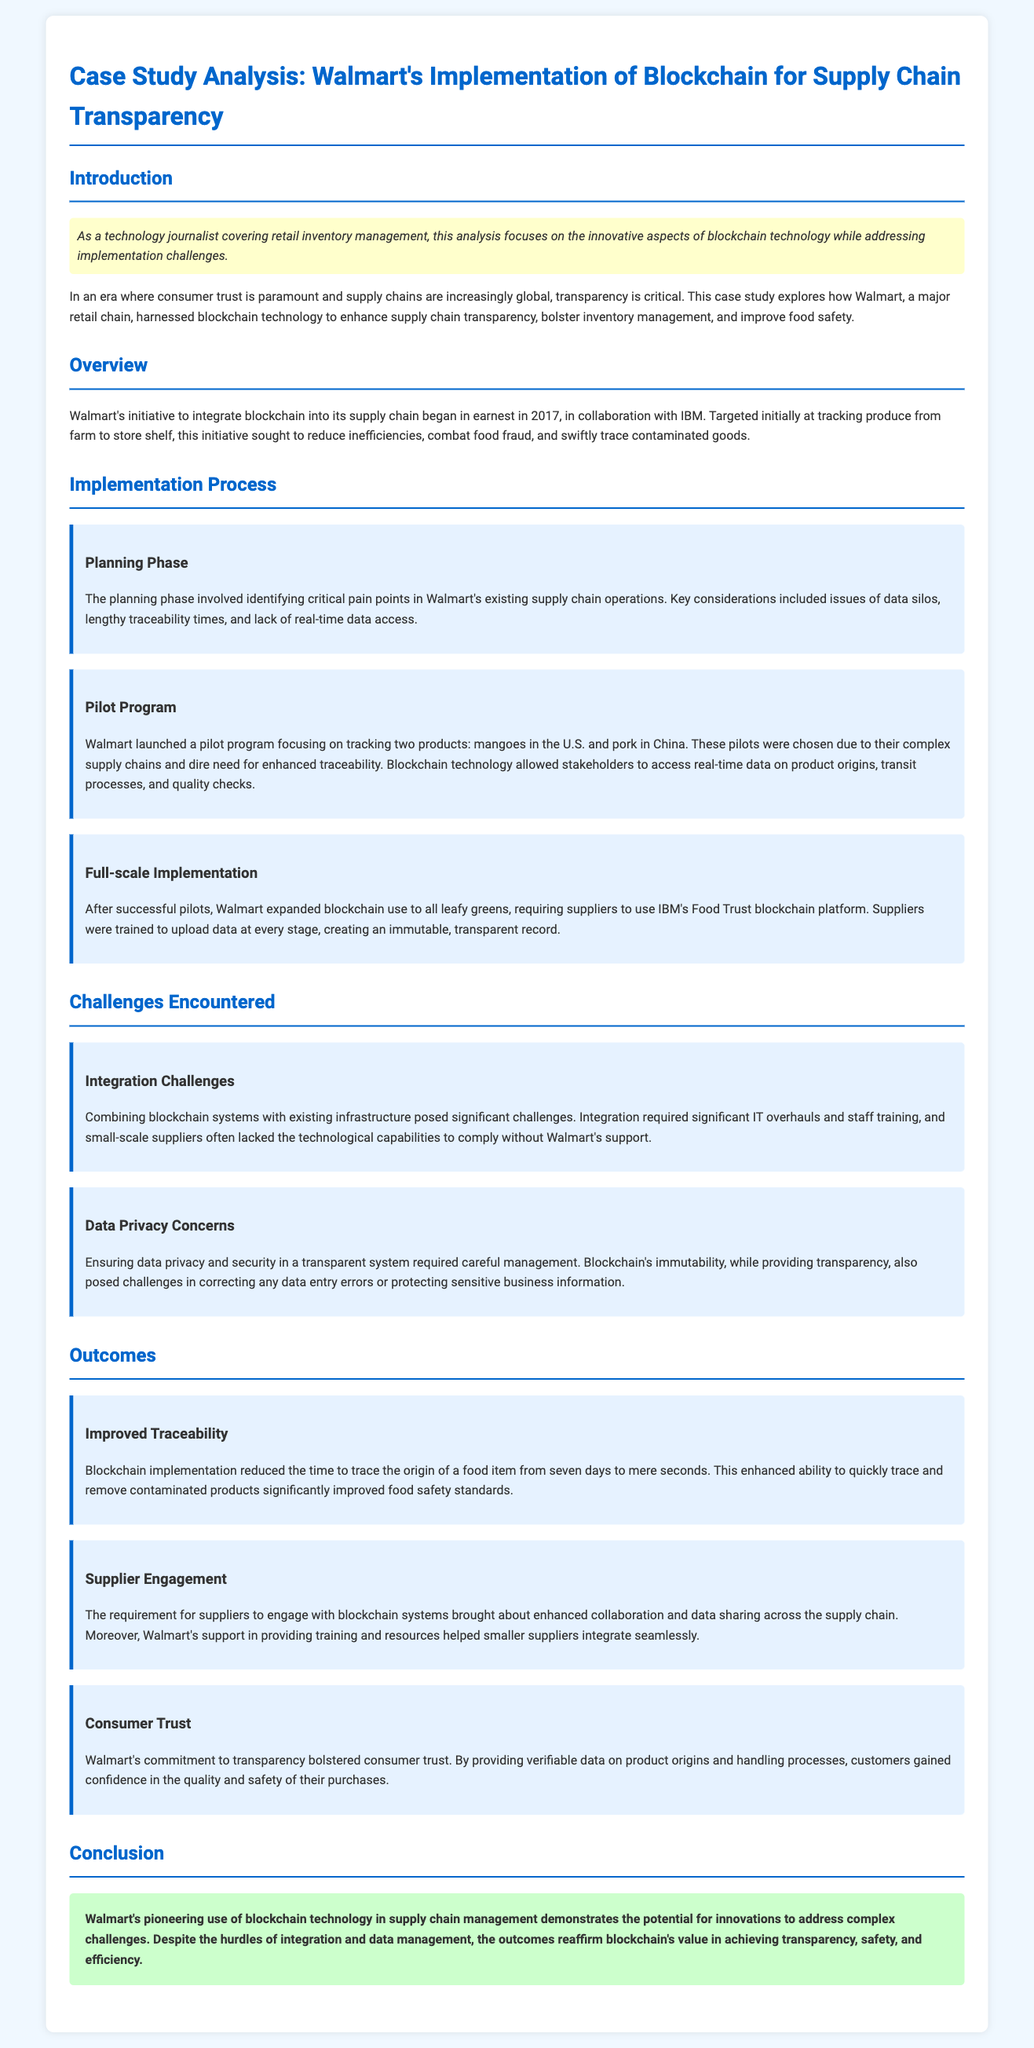What year did Walmart begin integrating blockchain with IBM? The document states that Walmart's initiative to integrate blockchain began in 2017.
Answer: 2017 What were the two products tracked during the pilot program? The pilot program focused on tracking mangoes in the U.S. and pork in China.
Answer: Mangoes and pork How much did the time to trace a food item's origin reduce to after blockchain implementation? The document mentions that the time to trace the origin decreased from seven days to mere seconds.
Answer: Mere seconds What primary challenge did Walmart encounter related to suppliers? The document indicates that small-scale suppliers often lacked the technological capabilities to comply without Walmart's support.
Answer: Technological capabilities What did Walmart require suppliers to use for full-scale implementation? The document specifies that suppliers were required to use IBM's Food Trust blockchain platform.
Answer: IBM's Food Trust blockchain platform What enhanced capability did blockchain provide regarding contaminated products? The implementation allowed stakeholders to quickly trace and remove contaminated products significantly, enhancing food safety standards.
Answer: Quickly trace and remove Which aspect of Walmart's initiative helped bolster consumer trust? The commitment to transparency provided verifiable data on product origins and handling processes.
Answer: Transparency What key consideration was identified in the planning phase? The planning phase included issues of data silos, lengthy traceability times, and lack of real-time data access as critical pain points.
Answer: Data silos, lengthy traceability times, lack of real-time data access What was one outcome of the improved engagement of suppliers with blockchain systems? The document states that it resulted in enhanced collaboration and data sharing across the supply chain.
Answer: Enhanced collaboration and data sharing 